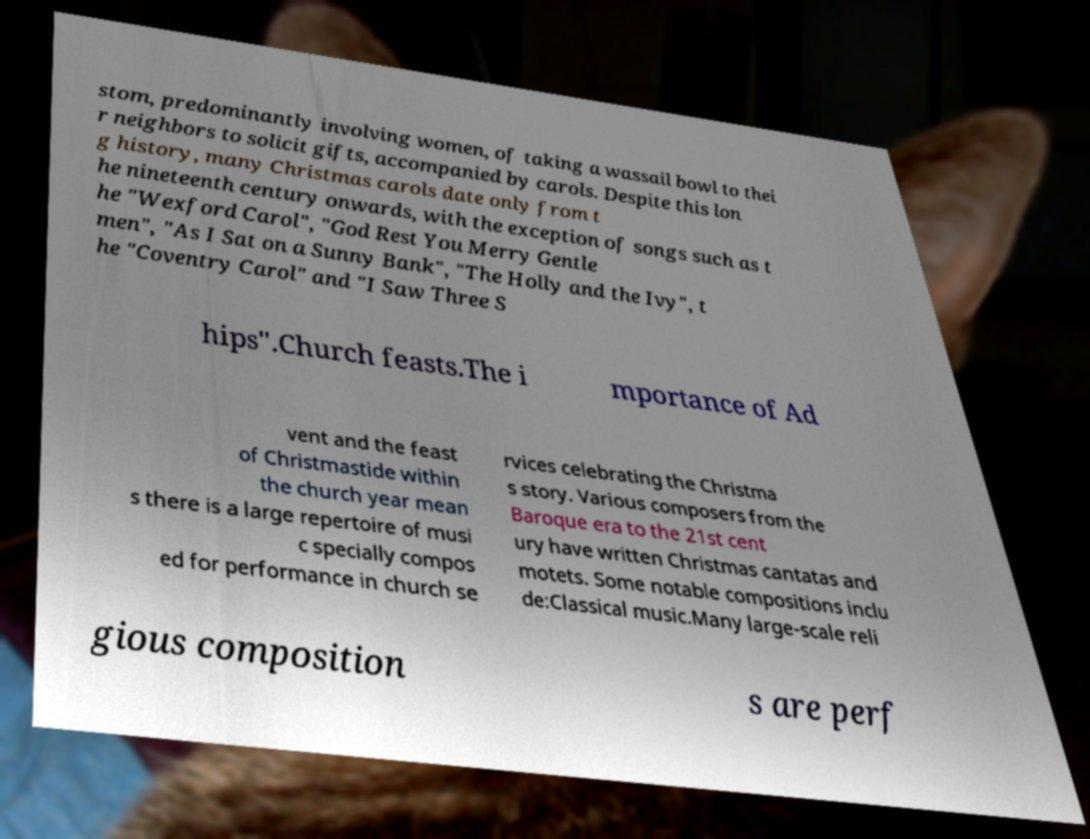For documentation purposes, I need the text within this image transcribed. Could you provide that? stom, predominantly involving women, of taking a wassail bowl to thei r neighbors to solicit gifts, accompanied by carols. Despite this lon g history, many Christmas carols date only from t he nineteenth century onwards, with the exception of songs such as t he "Wexford Carol", "God Rest You Merry Gentle men", "As I Sat on a Sunny Bank", "The Holly and the Ivy", t he "Coventry Carol" and "I Saw Three S hips".Church feasts.The i mportance of Ad vent and the feast of Christmastide within the church year mean s there is a large repertoire of musi c specially compos ed for performance in church se rvices celebrating the Christma s story. Various composers from the Baroque era to the 21st cent ury have written Christmas cantatas and motets. Some notable compositions inclu de:Classical music.Many large-scale reli gious composition s are perf 